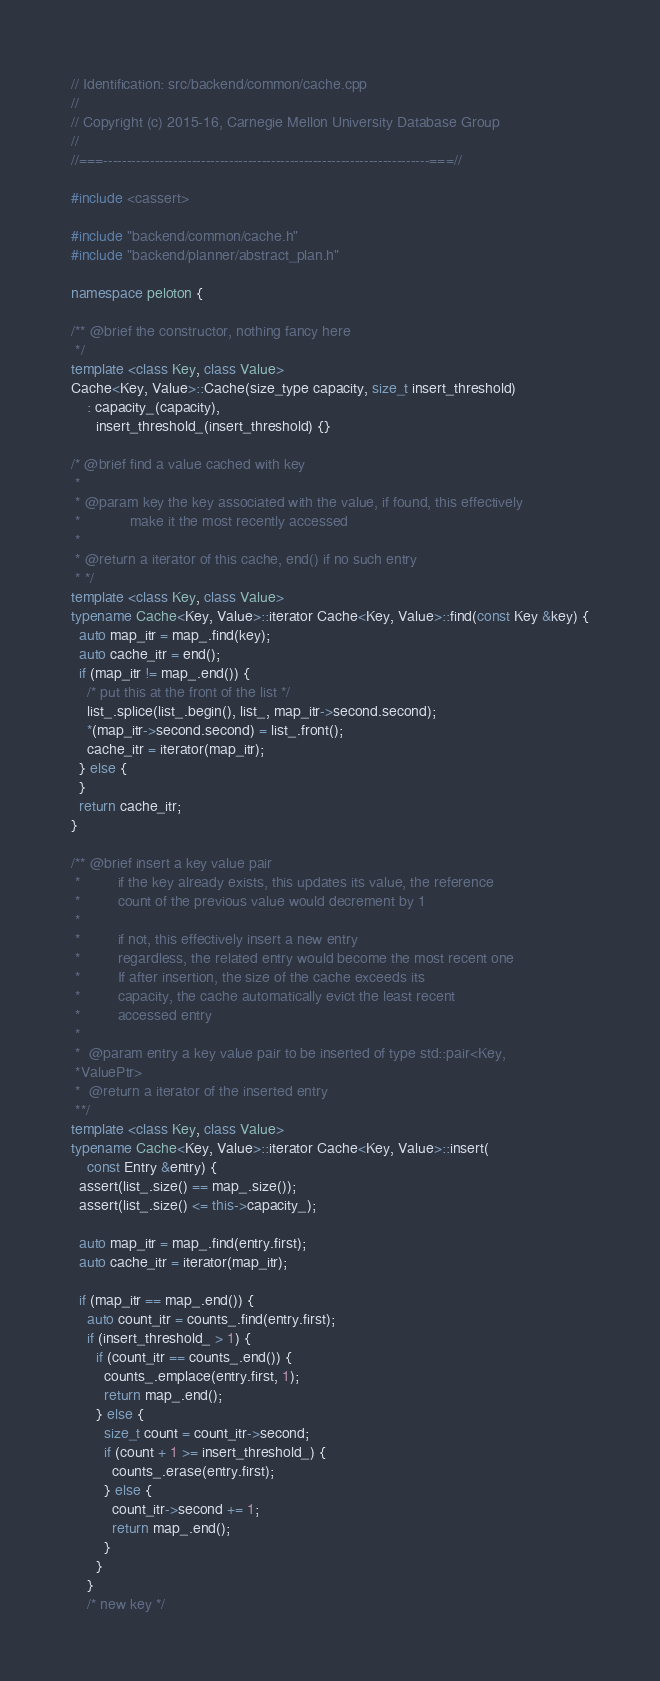<code> <loc_0><loc_0><loc_500><loc_500><_C++_>// Identification: src/backend/common/cache.cpp
//
// Copyright (c) 2015-16, Carnegie Mellon University Database Group
//
//===----------------------------------------------------------------------===//

#include <cassert>

#include "backend/common/cache.h"
#include "backend/planner/abstract_plan.h"

namespace peloton {

/** @brief the constructor, nothing fancy here
 */
template <class Key, class Value>
Cache<Key, Value>::Cache(size_type capacity, size_t insert_threshold)
    : capacity_(capacity),
      insert_threshold_(insert_threshold) {}

/* @brief find a value cached with key
 *
 * @param key the key associated with the value, if found, this effectively
 *            make it the most recently accessed
 *
 * @return a iterator of this cache, end() if no such entry
 * */
template <class Key, class Value>
typename Cache<Key, Value>::iterator Cache<Key, Value>::find(const Key &key) {
  auto map_itr = map_.find(key);
  auto cache_itr = end();
  if (map_itr != map_.end()) {
    /* put this at the front of the list */
    list_.splice(list_.begin(), list_, map_itr->second.second);
    *(map_itr->second.second) = list_.front();
    cache_itr = iterator(map_itr);
  } else {
  }
  return cache_itr;
}

/** @brief insert a key value pair
 *         if the key already exists, this updates its value, the reference
 *         count of the previous value would decrement by 1
 *
 *         if not, this effectively insert a new entry
 *         regardless, the related entry would become the most recent one
 *         If after insertion, the size of the cache exceeds its
 *         capacity, the cache automatically evict the least recent
 *         accessed entry
 *
 *  @param entry a key value pair to be inserted of type std::pair<Key,
 *ValuePtr>
 *  @return a iterator of the inserted entry
 **/
template <class Key, class Value>
typename Cache<Key, Value>::iterator Cache<Key, Value>::insert(
    const Entry &entry) {
  assert(list_.size() == map_.size());
  assert(list_.size() <= this->capacity_);

  auto map_itr = map_.find(entry.first);
  auto cache_itr = iterator(map_itr);

  if (map_itr == map_.end()) {
    auto count_itr = counts_.find(entry.first);
    if (insert_threshold_ > 1) {
      if (count_itr == counts_.end()) {
        counts_.emplace(entry.first, 1);
        return map_.end();
      } else {
        size_t count = count_itr->second;
        if (count + 1 >= insert_threshold_) {
          counts_.erase(entry.first);
        } else {
          count_itr->second += 1;
          return map_.end();
        }
      }
    }
    /* new key */</code> 